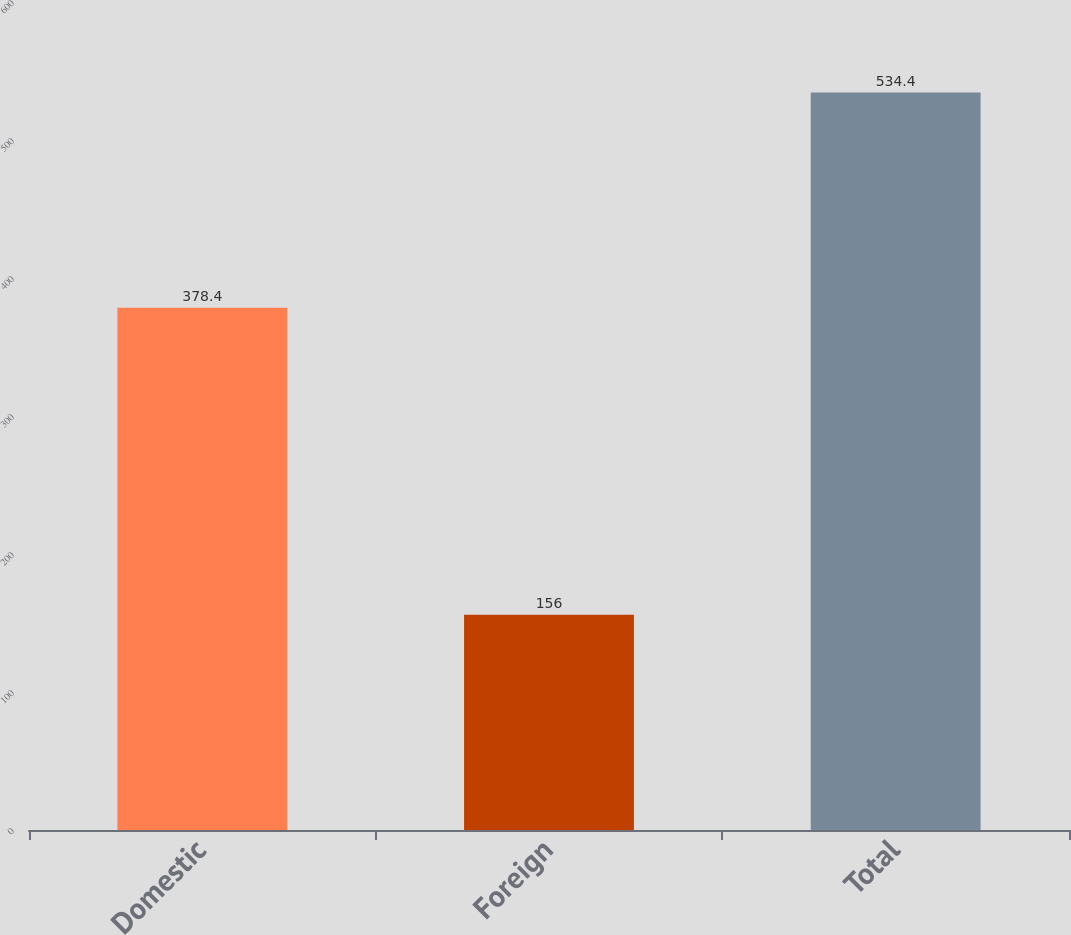<chart> <loc_0><loc_0><loc_500><loc_500><bar_chart><fcel>Domestic<fcel>Foreign<fcel>Total<nl><fcel>378.4<fcel>156<fcel>534.4<nl></chart> 